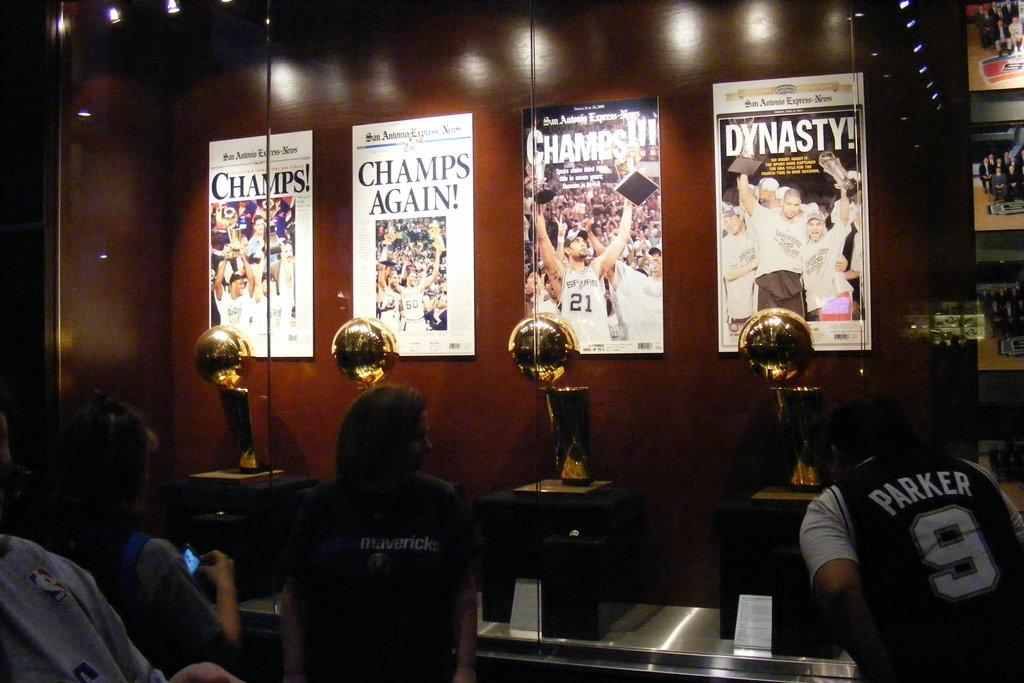<image>
Give a short and clear explanation of the subsequent image. A man wearing a sports top with the number 9 on it and the name Parker peers into case displaying 4 world cups, each beneath a newspaper headline above them. 